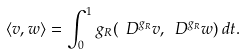<formula> <loc_0><loc_0><loc_500><loc_500>\langle v , w \rangle = \int _ { 0 } ^ { 1 } g _ { R } ( \ D ^ { g _ { R } } v , \ D ^ { g _ { R } } w ) \, d t .</formula> 